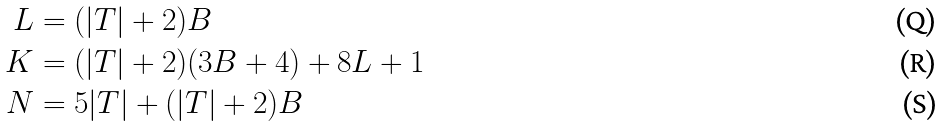<formula> <loc_0><loc_0><loc_500><loc_500>L & = ( | T | + 2 ) B \\ K & = ( | T | + 2 ) ( 3 B + 4 ) + 8 L + 1 \\ N & = 5 | T | + ( | T | + 2 ) B</formula> 